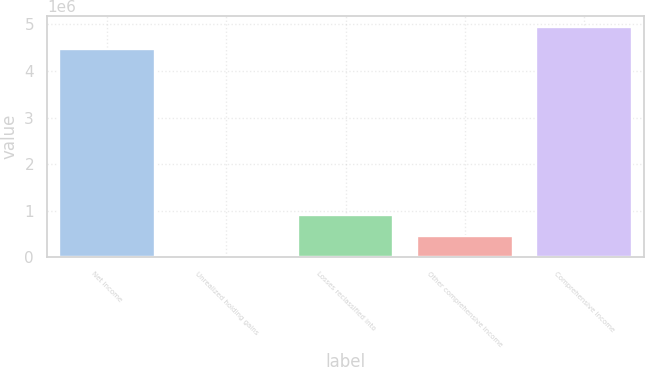<chart> <loc_0><loc_0><loc_500><loc_500><bar_chart><fcel>Net income<fcel>Unrealized holding gains<fcel>Losses reclassified into<fcel>Other comprehensive income<fcel>Comprehensive income<nl><fcel>4.4801e+06<fcel>3915<fcel>906774<fcel>455345<fcel>4.93153e+06<nl></chart> 